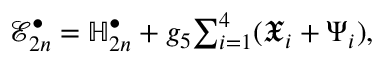<formula> <loc_0><loc_0><loc_500><loc_500>\mathcal { E } _ { 2 n } ^ { \bullet } = \mathbb { H } _ { 2 n } ^ { \bullet } + g _ { 5 } \sum _ { i = 1 } ^ { 4 } ( \mathfrak { X } _ { i } + \Psi _ { i } ) ,</formula> 